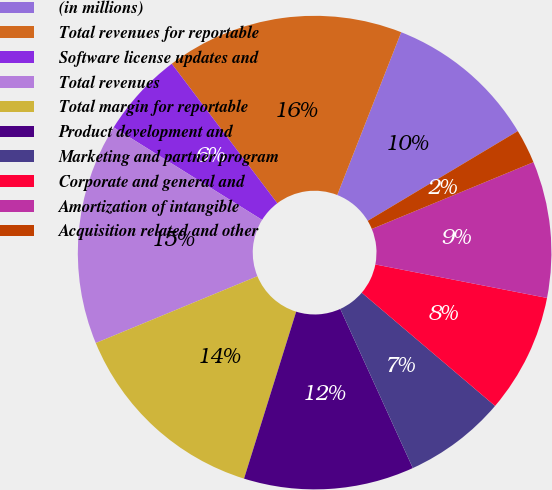Convert chart. <chart><loc_0><loc_0><loc_500><loc_500><pie_chart><fcel>(in millions)<fcel>Total revenues for reportable<fcel>Software license updates and<fcel>Total revenues<fcel>Total margin for reportable<fcel>Product development and<fcel>Marketing and partner program<fcel>Corporate and general and<fcel>Amortization of intangible<fcel>Acquisition related and other<nl><fcel>10.46%<fcel>16.26%<fcel>5.82%<fcel>15.1%<fcel>13.94%<fcel>11.62%<fcel>6.98%<fcel>8.14%<fcel>9.3%<fcel>2.34%<nl></chart> 